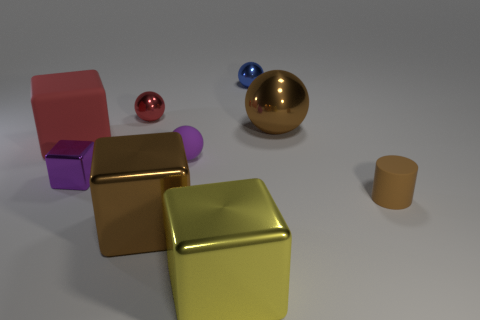The large block on the left side of the brown metal object that is in front of the big cube behind the tiny purple cube is what color?
Provide a succinct answer. Red. Are the brown object that is behind the red matte thing and the small red thing made of the same material?
Your response must be concise. Yes. Are there any rubber things of the same color as the large sphere?
Provide a short and direct response. Yes. Are there any large purple matte spheres?
Provide a succinct answer. No. There is a red object that is in front of the brown metal ball; is its size the same as the big yellow block?
Your answer should be very brief. Yes. Is the number of tiny cyan metal cylinders less than the number of large red blocks?
Make the answer very short. Yes. There is a big brown object to the left of the small purple thing on the right side of the large brown metal thing that is to the left of the small blue object; what shape is it?
Make the answer very short. Cube. Are there any large brown spheres made of the same material as the yellow object?
Offer a very short reply. Yes. Is the color of the large object to the right of the yellow thing the same as the tiny rubber cylinder in front of the big red block?
Provide a succinct answer. Yes. Are there fewer tiny matte cylinders behind the purple sphere than small objects?
Keep it short and to the point. Yes. 